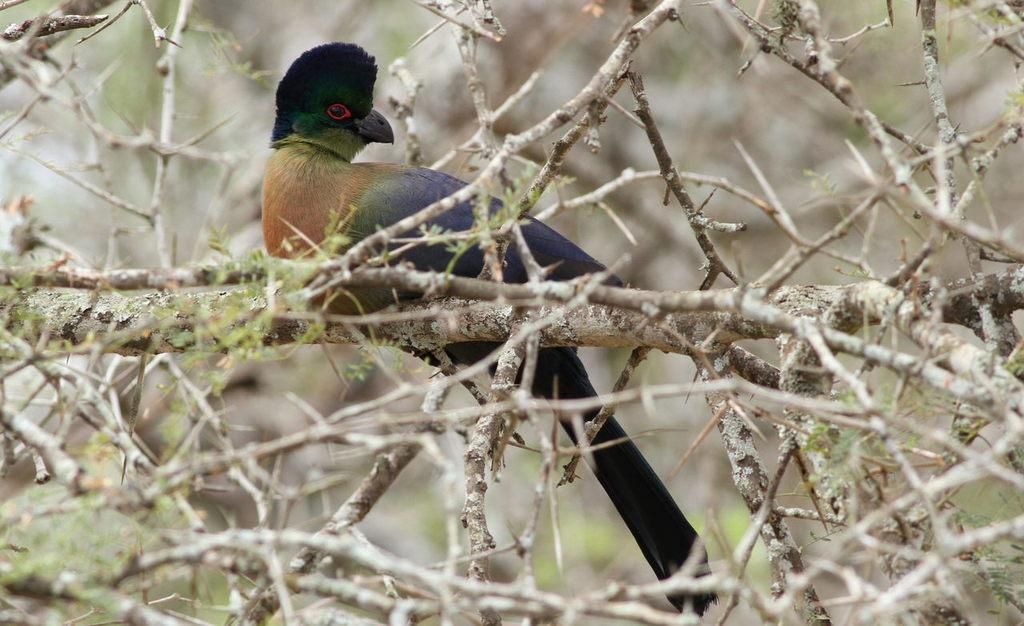What type of animal is in the image? There is a bird in the image. Where is the bird located? The bird is on a branch. Can you describe the background of the image? The background of the image is blurred. What type of snakes can be seen slithering in the image? There are no snakes present in the image; it features a bird on a branch. How does the bird sort the leaves in the image? The image does not show the bird sorting leaves, nor does it depict any leaves. 